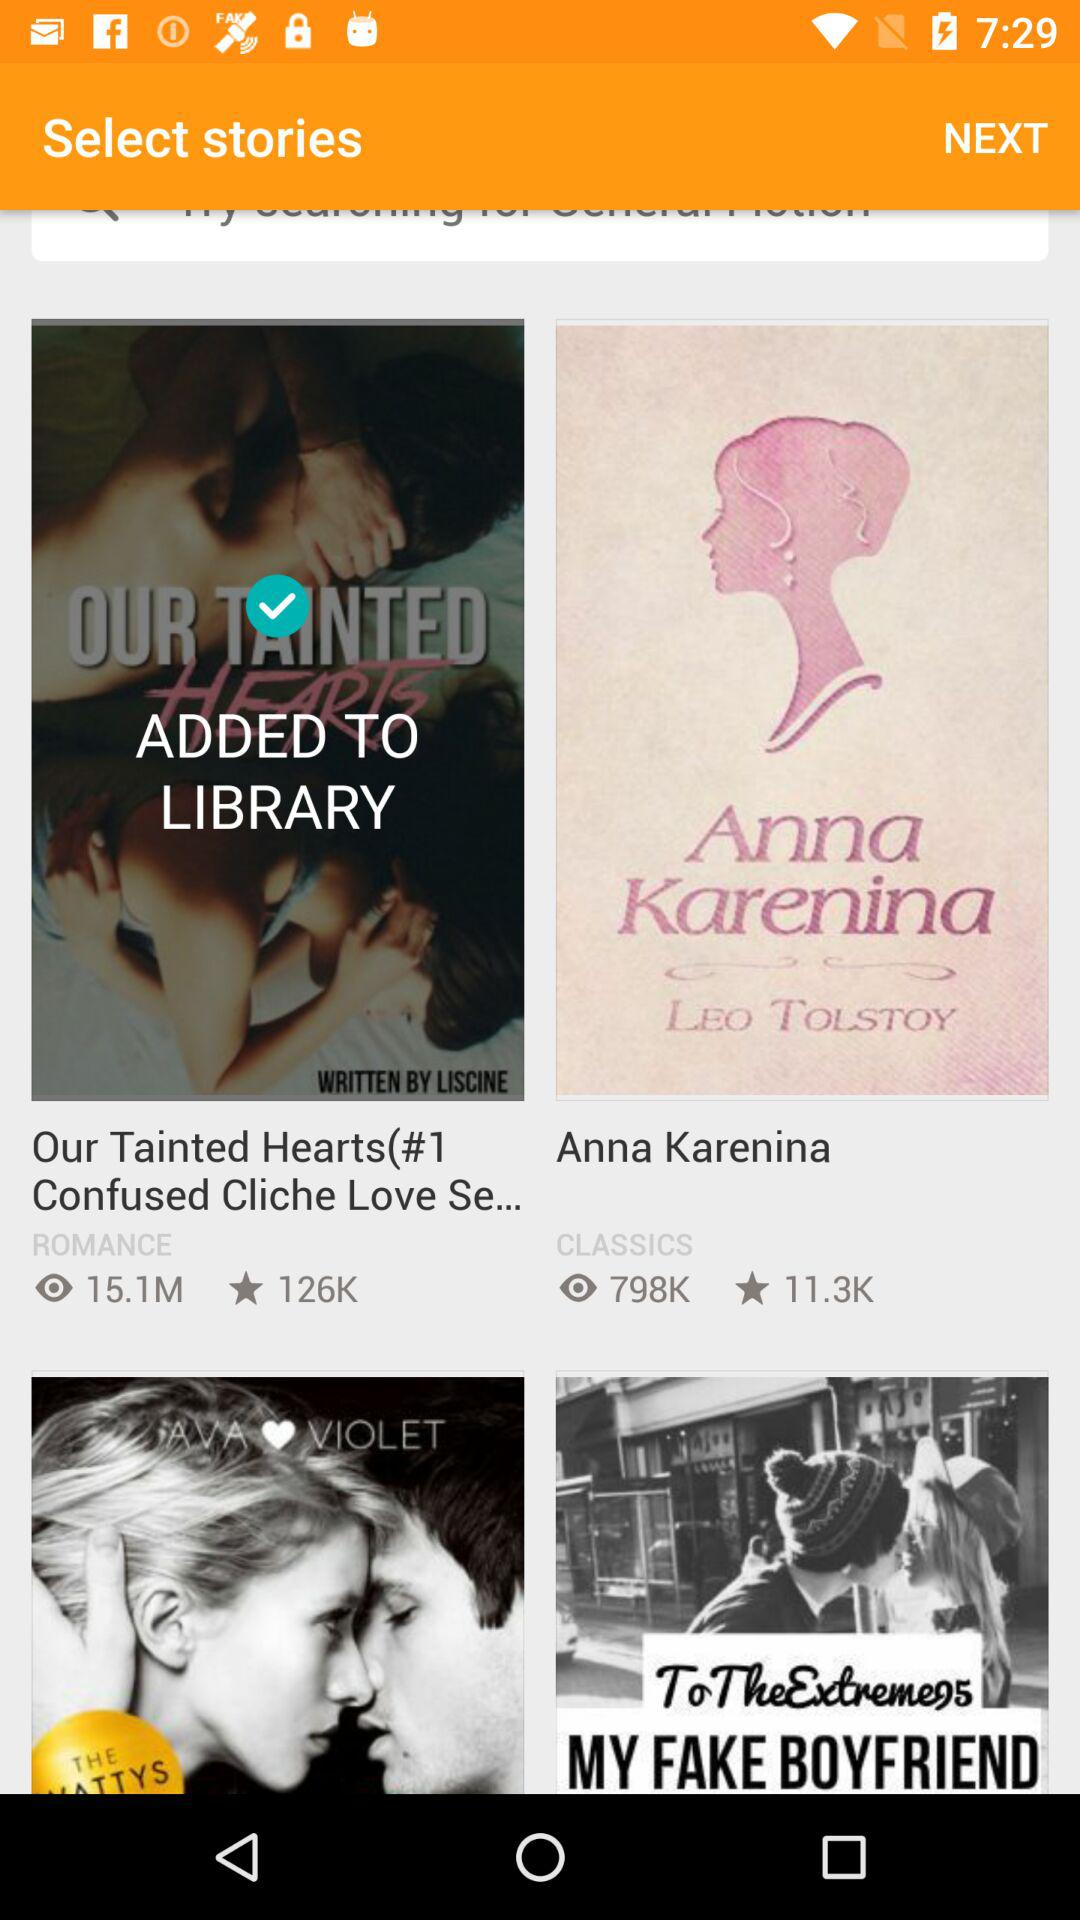Who is the author of "To The Extremes MY FAKE BOYFRIEND"?
When the provided information is insufficient, respond with <no answer>. <no answer> 